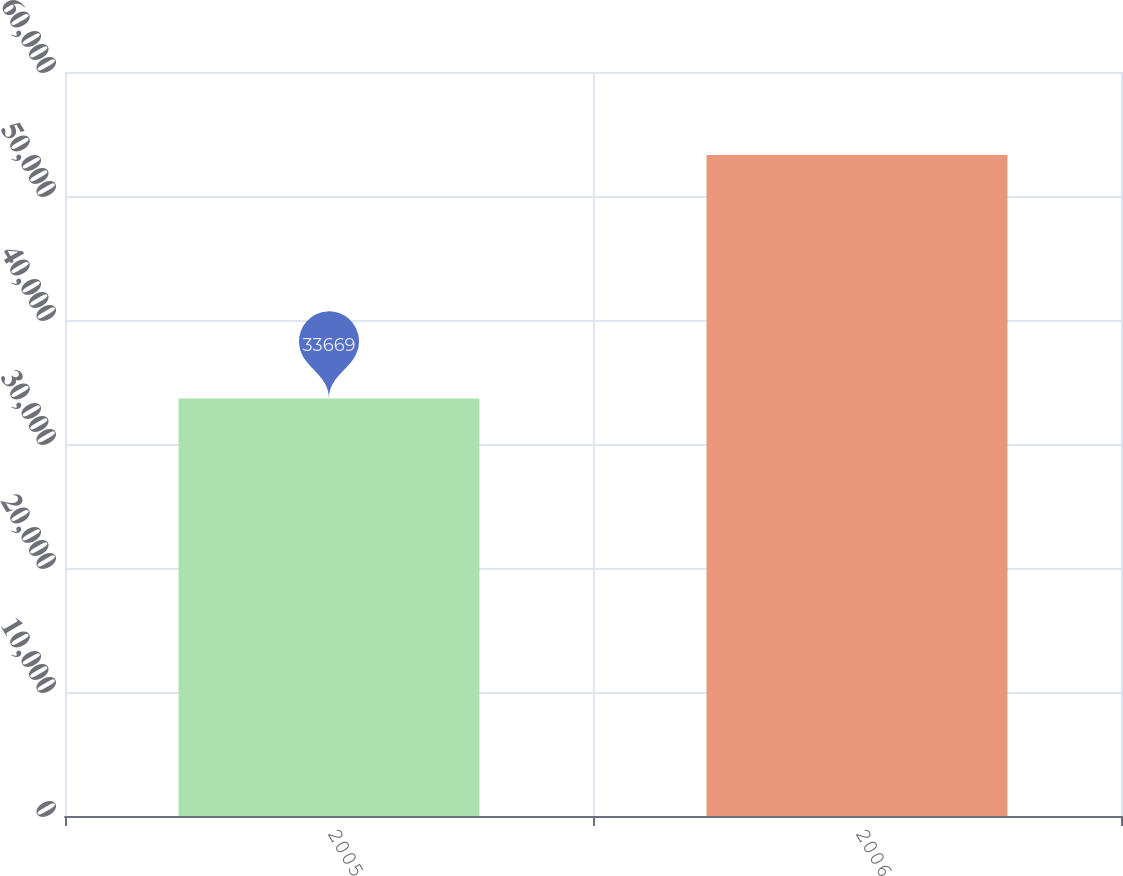Convert chart. <chart><loc_0><loc_0><loc_500><loc_500><bar_chart><fcel>2005<fcel>2006<nl><fcel>33669<fcel>53308<nl></chart> 